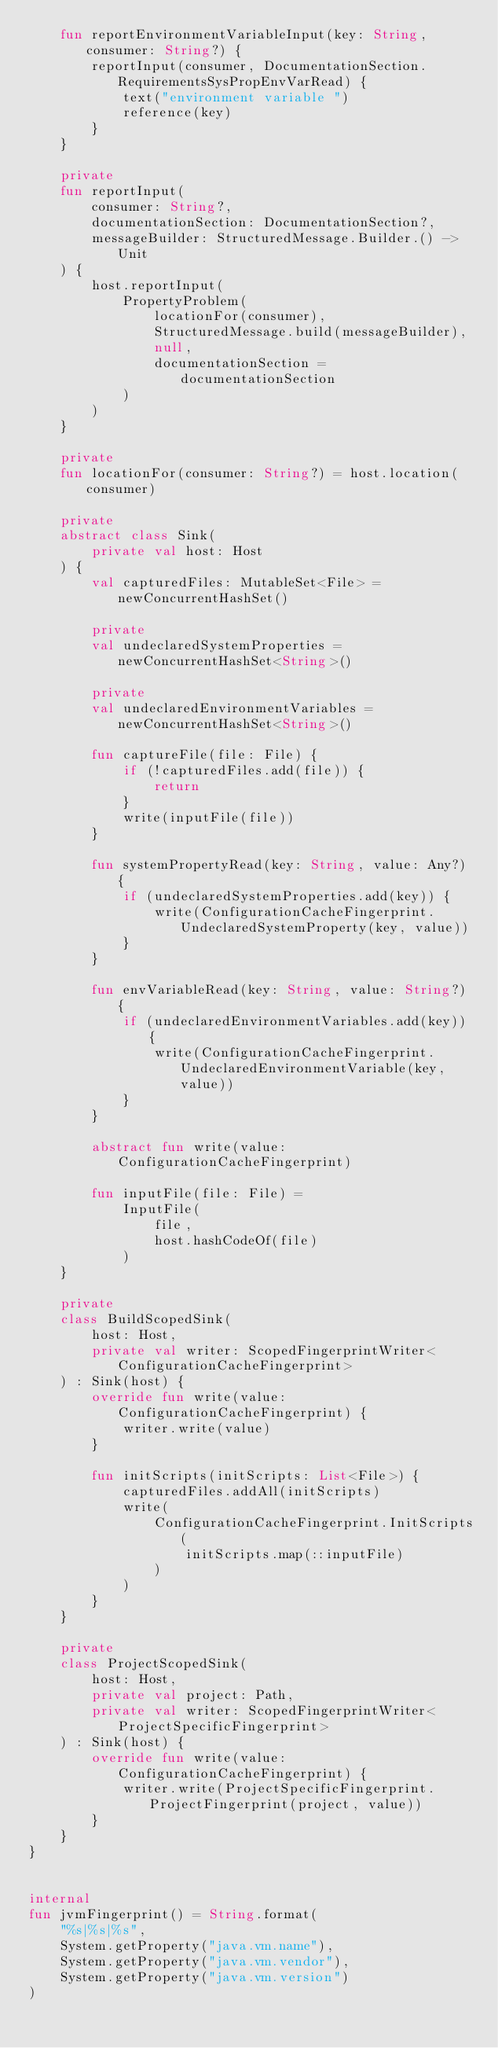<code> <loc_0><loc_0><loc_500><loc_500><_Kotlin_>    fun reportEnvironmentVariableInput(key: String, consumer: String?) {
        reportInput(consumer, DocumentationSection.RequirementsSysPropEnvVarRead) {
            text("environment variable ")
            reference(key)
        }
    }

    private
    fun reportInput(
        consumer: String?,
        documentationSection: DocumentationSection?,
        messageBuilder: StructuredMessage.Builder.() -> Unit
    ) {
        host.reportInput(
            PropertyProblem(
                locationFor(consumer),
                StructuredMessage.build(messageBuilder),
                null,
                documentationSection = documentationSection
            )
        )
    }

    private
    fun locationFor(consumer: String?) = host.location(consumer)

    private
    abstract class Sink(
        private val host: Host
    ) {
        val capturedFiles: MutableSet<File> = newConcurrentHashSet()

        private
        val undeclaredSystemProperties = newConcurrentHashSet<String>()

        private
        val undeclaredEnvironmentVariables = newConcurrentHashSet<String>()

        fun captureFile(file: File) {
            if (!capturedFiles.add(file)) {
                return
            }
            write(inputFile(file))
        }

        fun systemPropertyRead(key: String, value: Any?) {
            if (undeclaredSystemProperties.add(key)) {
                write(ConfigurationCacheFingerprint.UndeclaredSystemProperty(key, value))
            }
        }

        fun envVariableRead(key: String, value: String?) {
            if (undeclaredEnvironmentVariables.add(key)) {
                write(ConfigurationCacheFingerprint.UndeclaredEnvironmentVariable(key, value))
            }
        }

        abstract fun write(value: ConfigurationCacheFingerprint)

        fun inputFile(file: File) =
            InputFile(
                file,
                host.hashCodeOf(file)
            )
    }

    private
    class BuildScopedSink(
        host: Host,
        private val writer: ScopedFingerprintWriter<ConfigurationCacheFingerprint>
    ) : Sink(host) {
        override fun write(value: ConfigurationCacheFingerprint) {
            writer.write(value)
        }

        fun initScripts(initScripts: List<File>) {
            capturedFiles.addAll(initScripts)
            write(
                ConfigurationCacheFingerprint.InitScripts(
                    initScripts.map(::inputFile)
                )
            )
        }
    }

    private
    class ProjectScopedSink(
        host: Host,
        private val project: Path,
        private val writer: ScopedFingerprintWriter<ProjectSpecificFingerprint>
    ) : Sink(host) {
        override fun write(value: ConfigurationCacheFingerprint) {
            writer.write(ProjectSpecificFingerprint.ProjectFingerprint(project, value))
        }
    }
}


internal
fun jvmFingerprint() = String.format(
    "%s|%s|%s",
    System.getProperty("java.vm.name"),
    System.getProperty("java.vm.vendor"),
    System.getProperty("java.vm.version")
)
</code> 